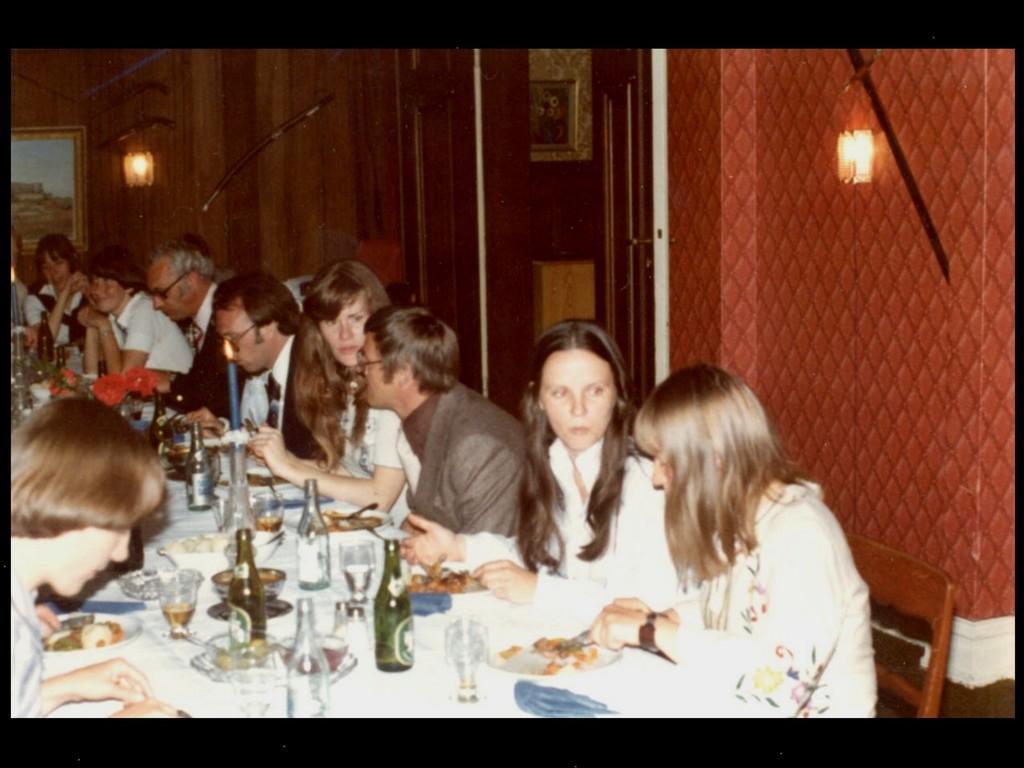In one or two sentences, can you explain what this image depicts? In the image we can see there are people who are sitting on chair and on table there are wine bottle and in plate there are food items. 